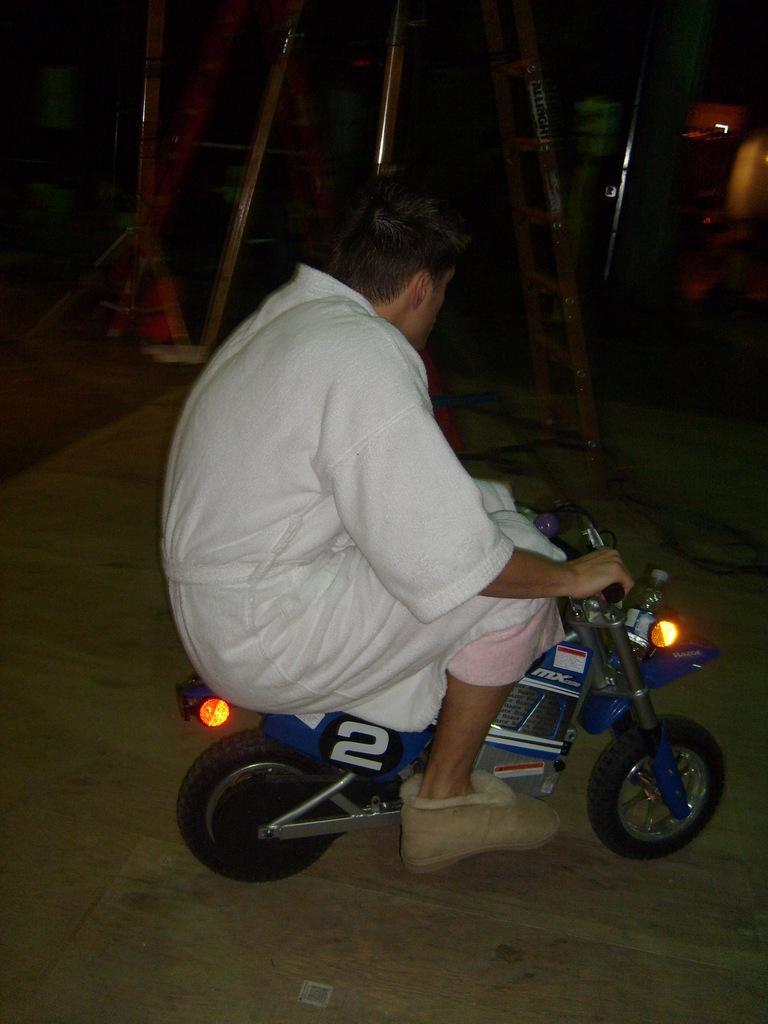How would you summarize this image in a sentence or two? a person is driving a bike. 